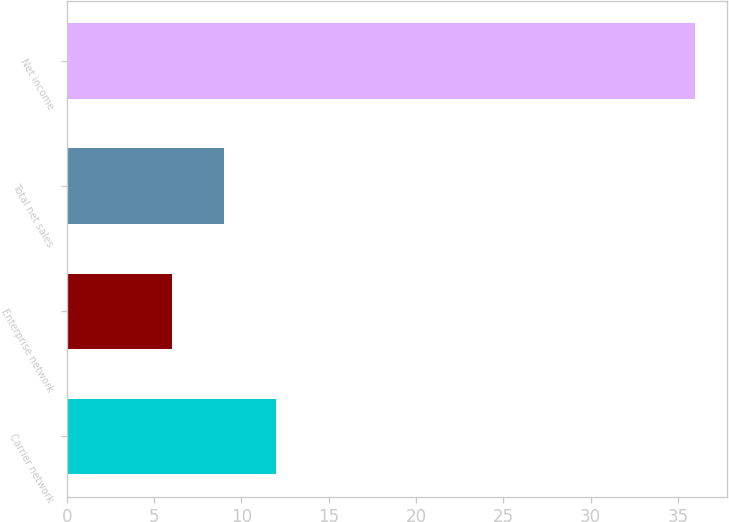Convert chart. <chart><loc_0><loc_0><loc_500><loc_500><bar_chart><fcel>Carrier network<fcel>Enterprise network<fcel>Total net sales<fcel>Net income<nl><fcel>12<fcel>6<fcel>9<fcel>36<nl></chart> 